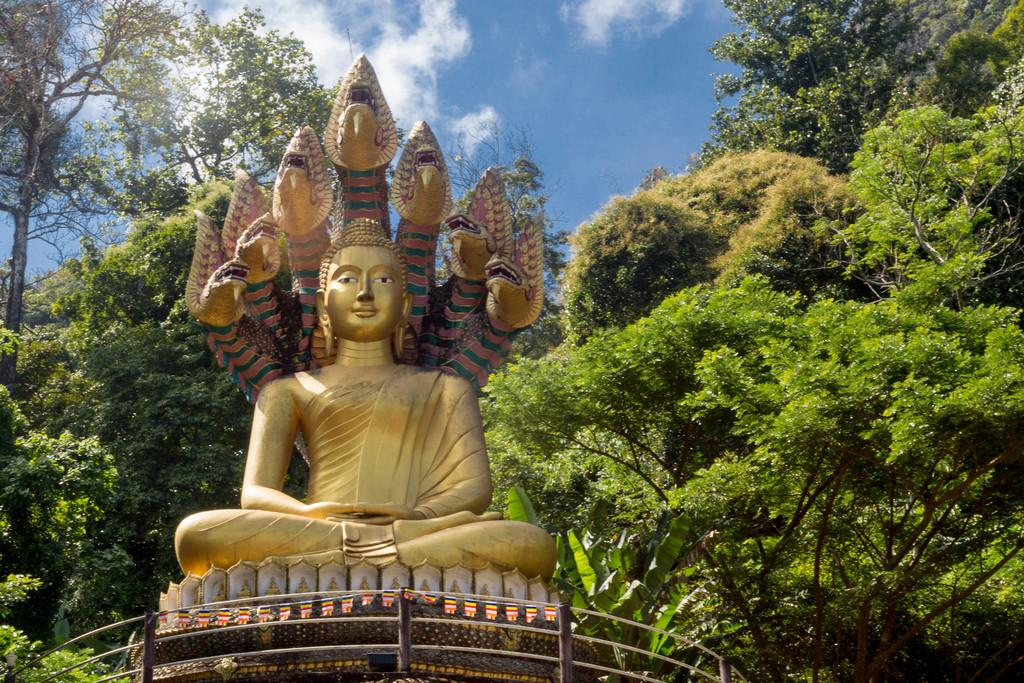What is the main subject in the center of the image? There is a statue in the center of the image. What can be seen in the background of the image? There are trees and the sky visible in the background of the image. What type of ink is being used to draw on the statue in the image? There is no ink or drawing present on the statue in the image. What time of day is depicted in the image? The time of day cannot be determined from the image, as there is no specific information about lighting or shadows. 